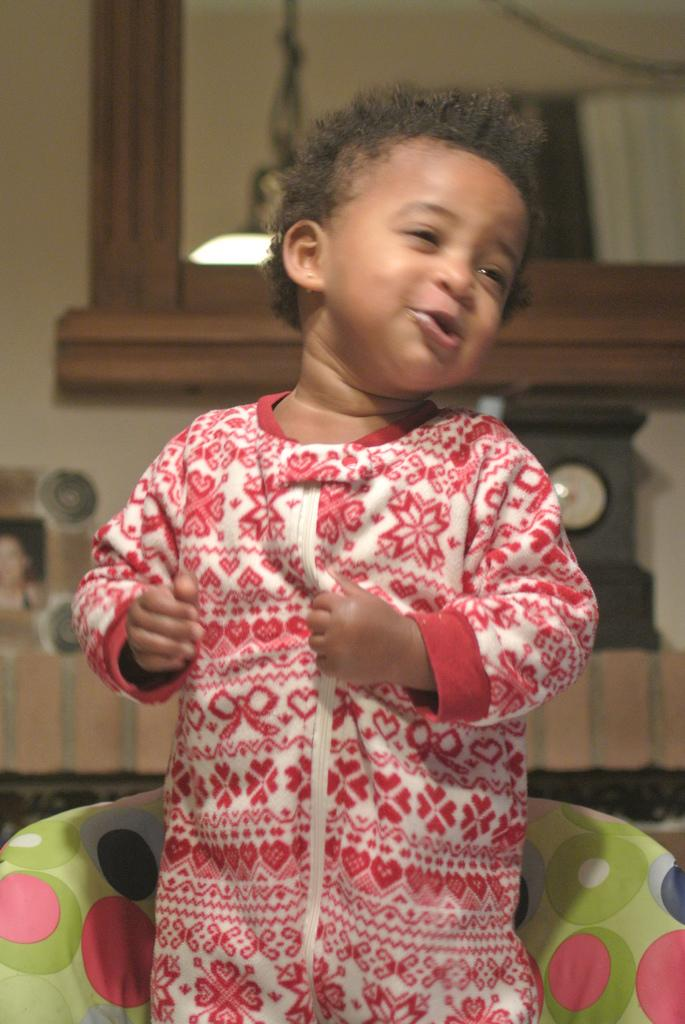What is the main subject of the image? There is a baby in the image. Can you describe the baby's attire? The baby is wearing a colorful dress. What is the baby's facial expression? The baby is smiling. What can be seen on the wall behind the baby? There is a mirror attached to the wall behind the baby. What type of oatmeal is the baby eating in the image? There is no oatmeal present in the image; the baby is not eating anything. What does the baby feel ashamed about in the image? The baby is smiling and there is no indication of shame in the image. 